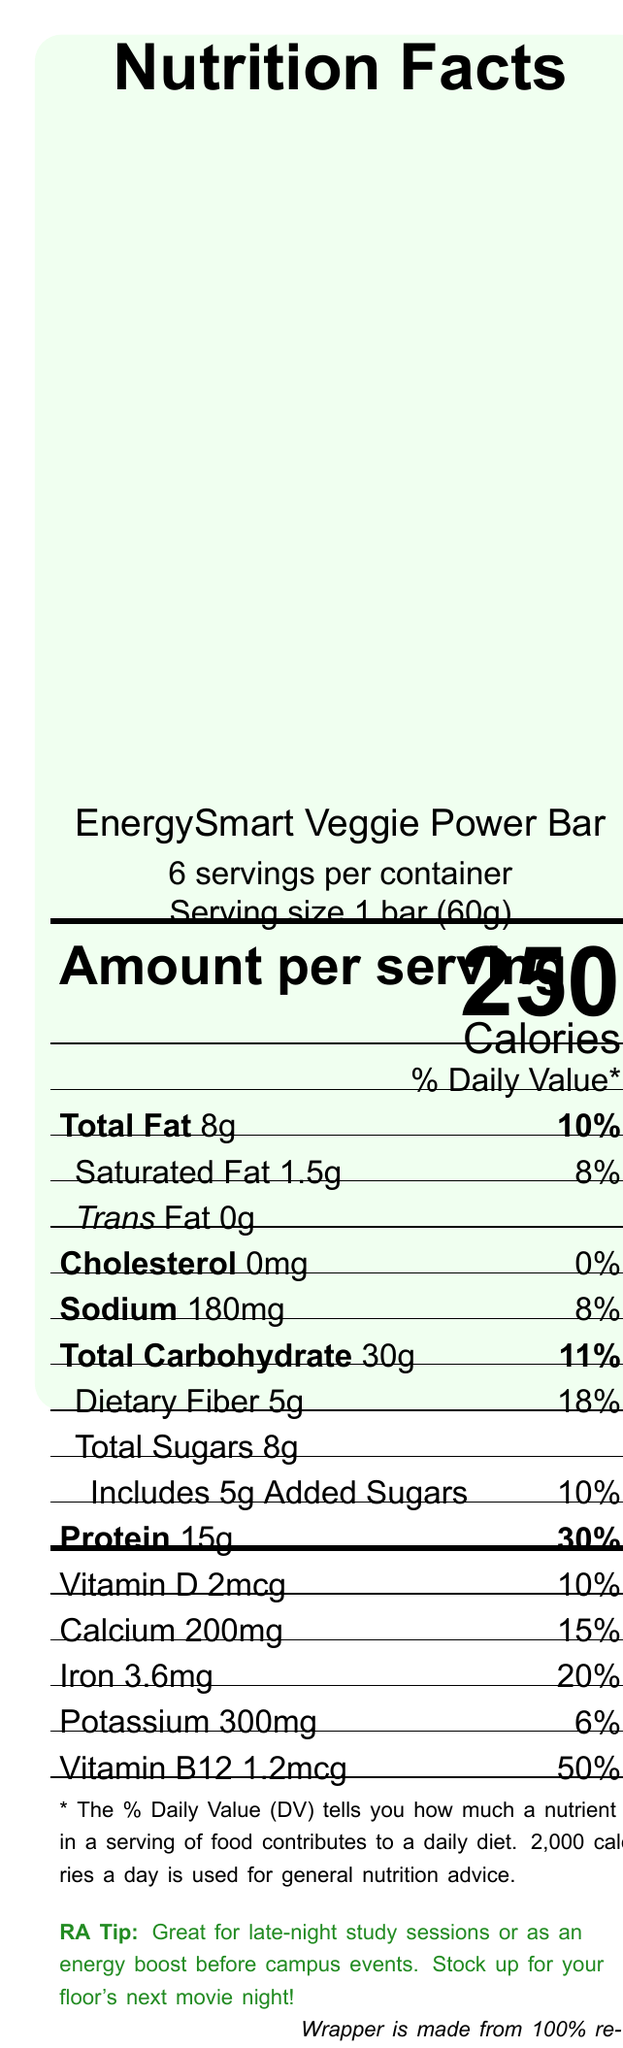what is the serving size of the EnergySmart Veggie Power Bar? The serving size is clearly stated near the top of the document.
Answer: 1 bar (60g) how many servings are in one container of the EnergySmart Veggie Power Bar? The document specifies there are 6 servings per container.
Answer: 6 how many calories per serving does the EnergySmart Veggie Power Bar contain? The calorie content per serving is prominently displayed in the 'Amount per serving' section.
Answer: 250 calories what is the total amount of fat per serving, and what percentage of the Daily Value does it represent? The document indicates that there are 8 grams of total fat per serving, representing 10% of the Daily Value.
Answer: 8g, 10% how many grams of added sugars does the EnergySmart Veggie Power Bar have? The added sugars amount is listed under the total sugars section.
Answer: 5g what types of allergens are present in the EnergySmart Veggie Power Bar? The allergen information specifies that it contains soy and tree nuts (almonds).
Answer: Soy and tree nuts (almonds) how much protein is in one serving of the EnergySmart Veggie Power Bar? A. 5g B. 10g C. 15g D. 20g According to the document, each serving contains 15 grams of protein.
Answer: C. 15g what percentage of the Daily Value of Vitamin B12 does one serving of the EnergySmart Veggie Power Bar provide? A. 10% B. 20% C. 30% D. 50% The document shows that one serving provides 50% of the Daily Value for Vitamin B12.
Answer: D. 50% does the EnergySmart Veggie Power Bar contain any trans fat? The document states that the amount of trans fat is 0g.
Answer: No is the EnergySmart Veggie Power Bar suitable for a post-workout snack? The recommended use section mentions that it is perfect for a post-workout snack.
Answer: Yes what are the main recommendations in the resident assistant note? The resident assistant note provides these recommendations for use.
Answer: Great for late-night study sessions or as an energy boost before campus events, and stocking up for a floor's next movie night describe the overall nutritional content of the EnergySmart Veggie Power Bar. The document lists comprehensive nutritional information per serving, including macronutrients (fats, carbohydrates, protein), sugars, and various vitamins and minerals along with their corresponding daily values.
Answer: The EnergySmart Veggie Power Bar contains 250 calories per serving, with 8g total fat, 1.5g saturated fat, 0g trans fat, 180mg sodium, 30g total carbohydrate, 5g dietary fiber, 8g total sugars including 5g added sugars, 15g protein, along with vitamins and minerals like Vitamin D, calcium, iron, potassium, and Vitamin B12, each contributing to a portion of the daily value. what storage instructions are provided for the EnergySmart Veggie Power Bar? The storage instructions detail how to store the bars and when to consume them once opened.
Answer: Store in a cool, dry place. Consume within 7 days of opening. what ingredients are used in the EnergySmart Veggie Power Bar? The ingredients section lists all components used in the bar.
Answer: Soy protein isolate, Brown rice syrup, Almonds, Dried cranberries, Pea protein, Oats, Sunflower seeds, Flaxseed, Chia seeds, Natural flavors, Sea salt is the wrapper of the EnergySmart Veggie Power Bar recyclable? The sustainability note mentions that the wrapper is made from 100% recycled materials and asks to recycle it.
Answer: Yes how would you describe the main features of the EnergySmart Veggie Power Bar? The main features include nutritional content, serving size, ingredients, allergens, storage instructions, use recommendations, sustainability note, and RA tips.
Answer: It is a protein-rich, vegetarian meal replacement bar containing 250 calories per serving, suitable for busy college students. It includes various vital nutrients, has allergen information, and comes with useful recommendations and sustainability notes. how much Vitamin C does the EnergySmart Veggie Power Bar contain? The document does not provide the amount of Vitamin C in the product.
Answer: Not enough information 